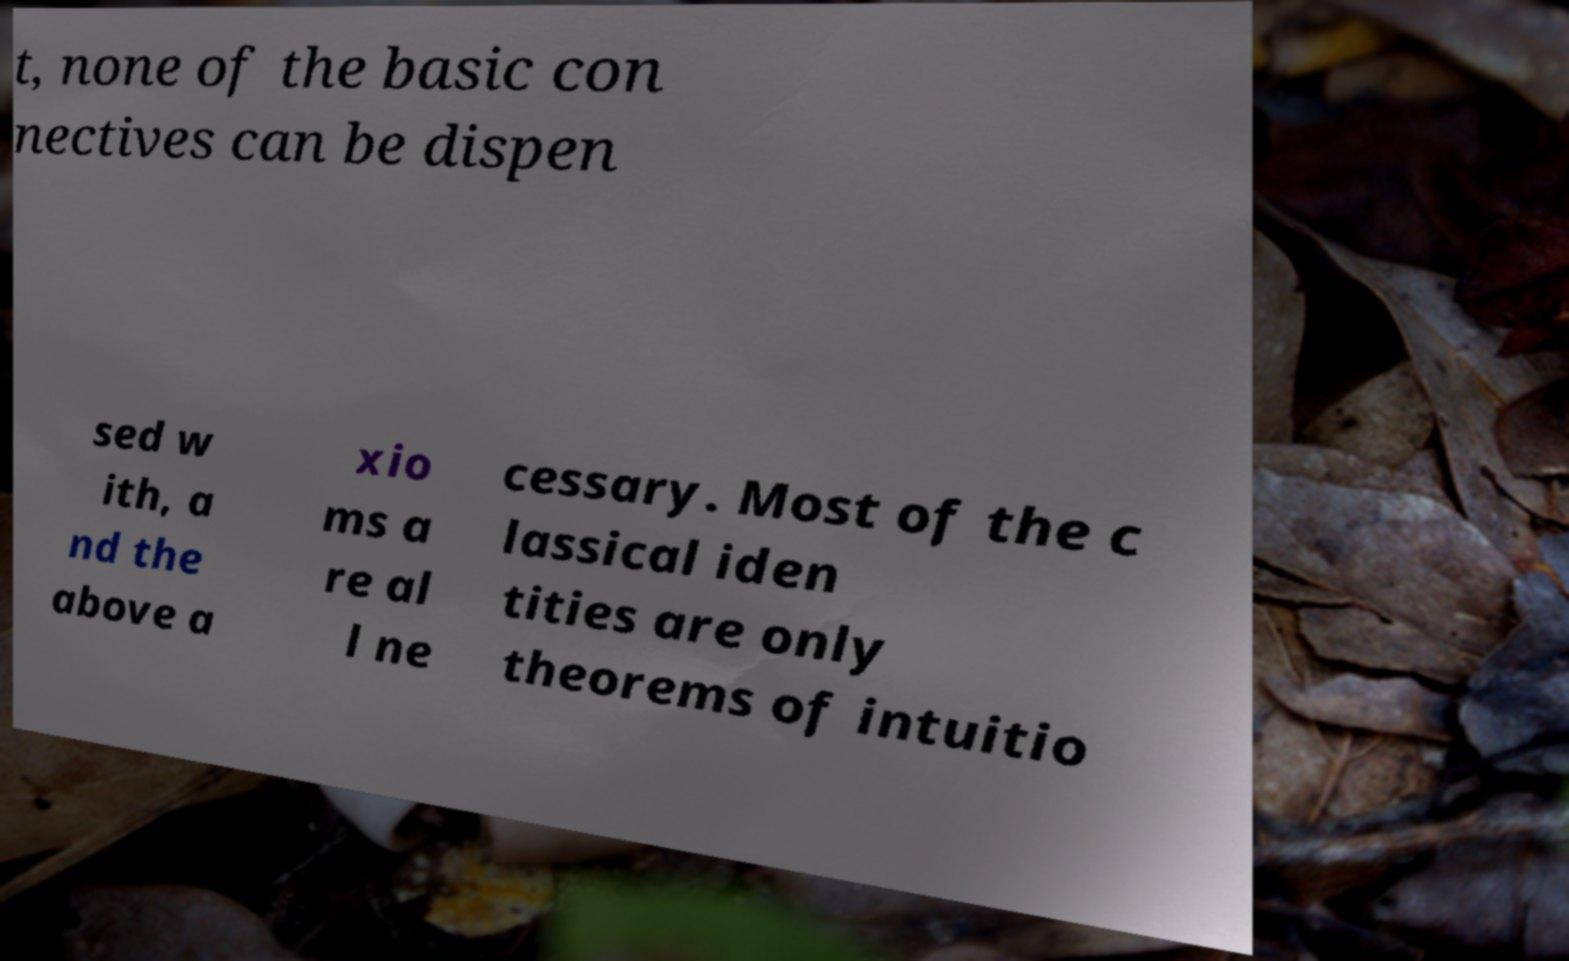Can you read and provide the text displayed in the image?This photo seems to have some interesting text. Can you extract and type it out for me? t, none of the basic con nectives can be dispen sed w ith, a nd the above a xio ms a re al l ne cessary. Most of the c lassical iden tities are only theorems of intuitio 